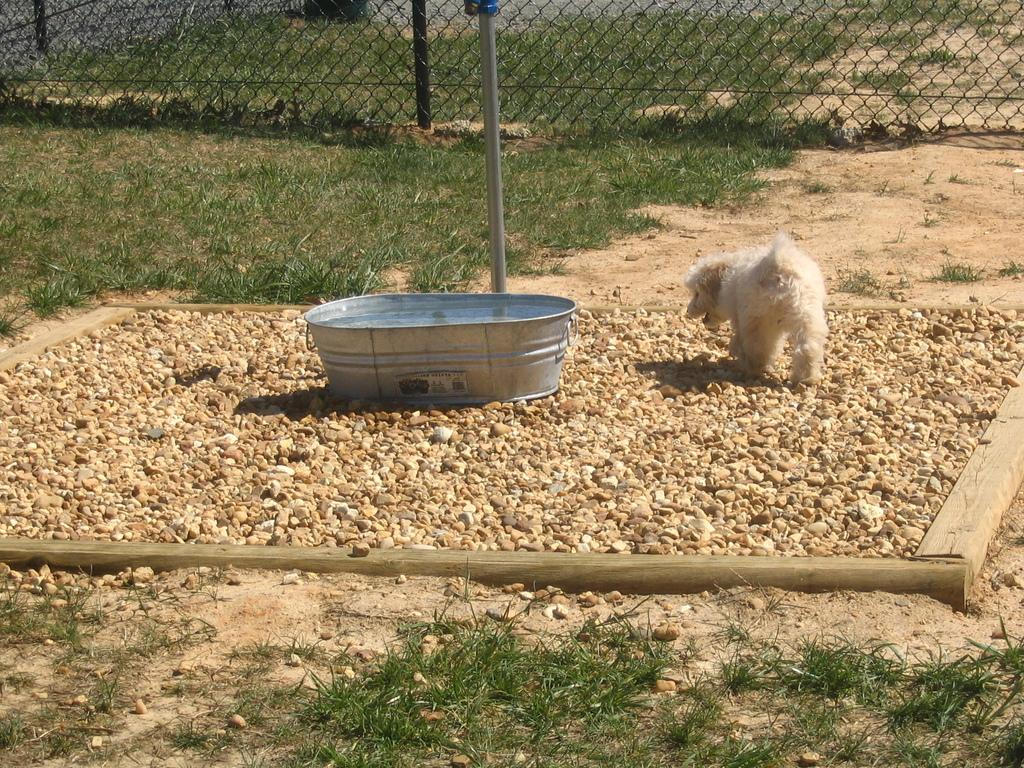What type of animal is present in the image? There is a dog in the image. What type of terrain is visible in the image? There are stones and grass in the image. What type of barrier is present in the image? There is a fence in the image. What type of structure is present in the image? There is a pole in the image. What type of object is present for holding or storing items? There is a container in the image. What type of milk is being poured into the container in the image? There is no milk present in the image; it only features a dog, stones, grass, a fence, a pole, and a container. 